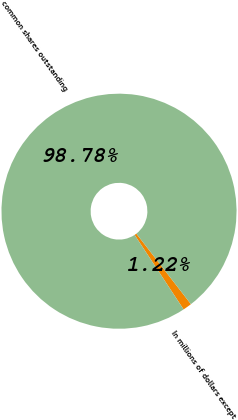Convert chart to OTSL. <chart><loc_0><loc_0><loc_500><loc_500><pie_chart><fcel>In millions of dollars except<fcel>common shares outstanding<nl><fcel>1.22%<fcel>98.78%<nl></chart> 